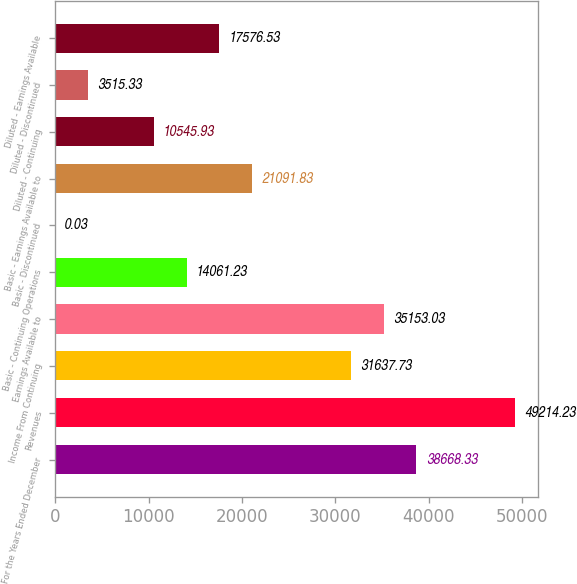Convert chart. <chart><loc_0><loc_0><loc_500><loc_500><bar_chart><fcel>For the Years Ended December<fcel>Revenues<fcel>Income From Continuing<fcel>Earnings Available to<fcel>Basic - Continuing Operations<fcel>Basic - Discontinued<fcel>Basic - Earnings Available to<fcel>Diluted - Continuing<fcel>Diluted - Discontinued<fcel>Diluted - Earnings Available<nl><fcel>38668.3<fcel>49214.2<fcel>31637.7<fcel>35153<fcel>14061.2<fcel>0.03<fcel>21091.8<fcel>10545.9<fcel>3515.33<fcel>17576.5<nl></chart> 